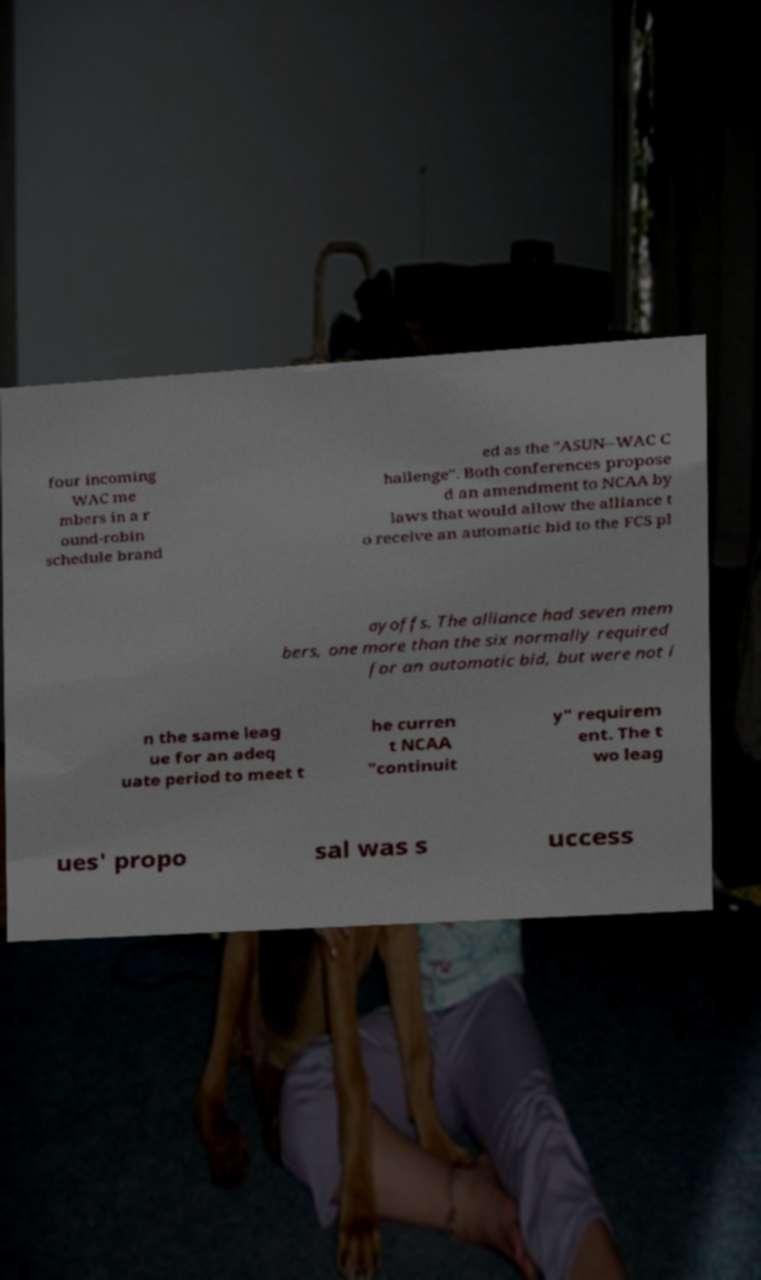Could you assist in decoding the text presented in this image and type it out clearly? four incoming WAC me mbers in a r ound-robin schedule brand ed as the "ASUN–WAC C hallenge". Both conferences propose d an amendment to NCAA by laws that would allow the alliance t o receive an automatic bid to the FCS pl ayoffs. The alliance had seven mem bers, one more than the six normally required for an automatic bid, but were not i n the same leag ue for an adeq uate period to meet t he curren t NCAA "continuit y" requirem ent. The t wo leag ues' propo sal was s uccess 